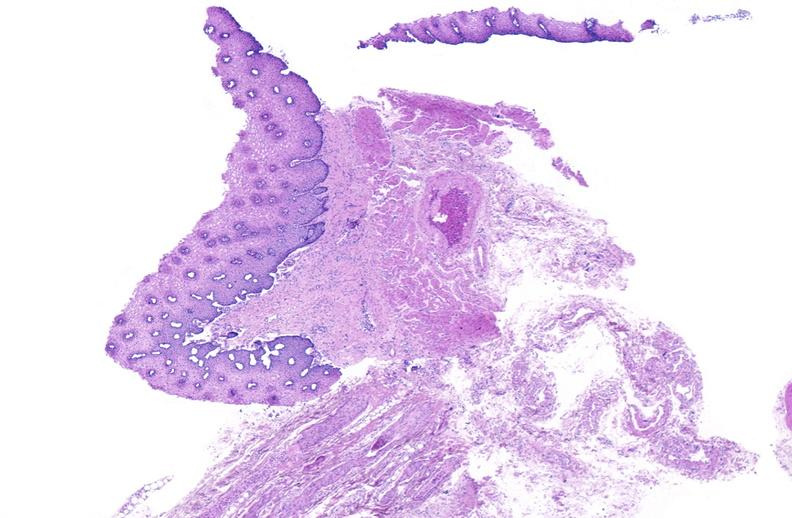does normal ovary show esophagus, varices?
Answer the question using a single word or phrase. No 